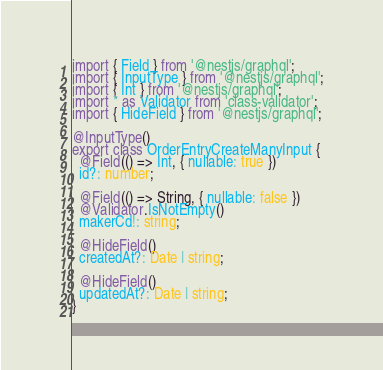<code> <loc_0><loc_0><loc_500><loc_500><_TypeScript_>import { Field } from '@nestjs/graphql';
import { InputType } from '@nestjs/graphql';
import { Int } from '@nestjs/graphql';
import * as Validator from 'class-validator';
import { HideField } from '@nestjs/graphql';

@InputType()
export class OrderEntryCreateManyInput {
  @Field(() => Int, { nullable: true })
  id?: number;

  @Field(() => String, { nullable: false })
  @Validator.IsNotEmpty()
  makerCd!: string;

  @HideField()
  createdAt?: Date | string;

  @HideField()
  updatedAt?: Date | string;
}
</code> 